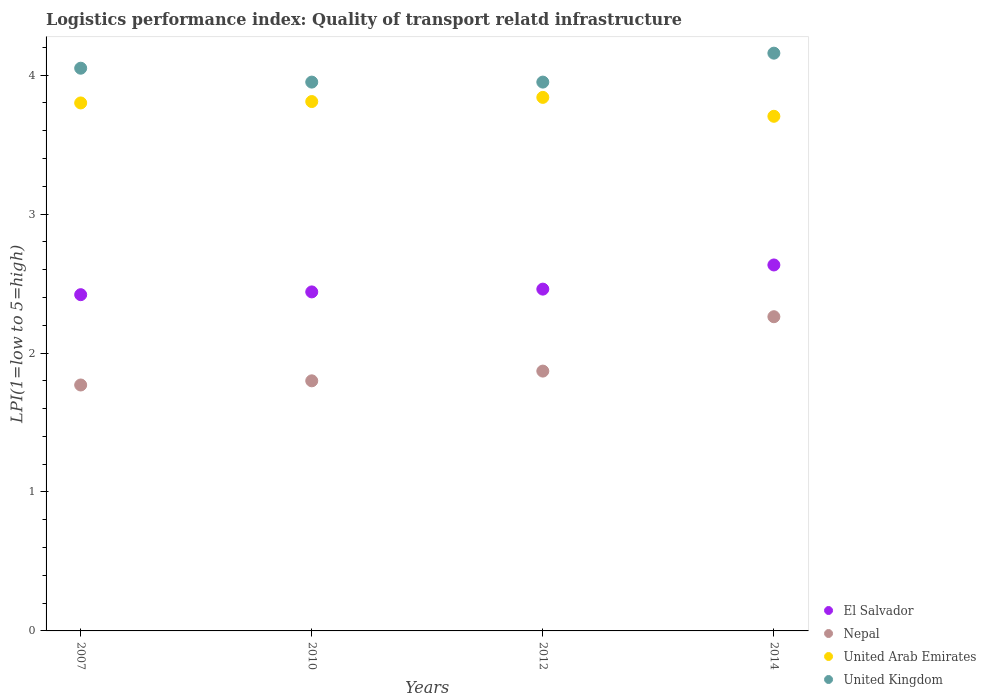How many different coloured dotlines are there?
Give a very brief answer. 4. Is the number of dotlines equal to the number of legend labels?
Provide a short and direct response. Yes. What is the logistics performance index in United Kingdom in 2012?
Make the answer very short. 3.95. Across all years, what is the maximum logistics performance index in United Arab Emirates?
Provide a short and direct response. 3.84. Across all years, what is the minimum logistics performance index in United Kingdom?
Your answer should be very brief. 3.95. What is the total logistics performance index in United Kingdom in the graph?
Give a very brief answer. 16.11. What is the difference between the logistics performance index in United Kingdom in 2012 and that in 2014?
Offer a terse response. -0.21. What is the difference between the logistics performance index in United Arab Emirates in 2012 and the logistics performance index in Nepal in 2010?
Provide a succinct answer. 2.04. What is the average logistics performance index in Nepal per year?
Keep it short and to the point. 1.93. In the year 2010, what is the difference between the logistics performance index in El Salvador and logistics performance index in United Kingdom?
Make the answer very short. -1.51. In how many years, is the logistics performance index in United Arab Emirates greater than 0.2?
Keep it short and to the point. 4. What is the ratio of the logistics performance index in El Salvador in 2007 to that in 2012?
Your response must be concise. 0.98. What is the difference between the highest and the second highest logistics performance index in El Salvador?
Provide a short and direct response. 0.17. What is the difference between the highest and the lowest logistics performance index in Nepal?
Keep it short and to the point. 0.49. Is the sum of the logistics performance index in El Salvador in 2012 and 2014 greater than the maximum logistics performance index in United Kingdom across all years?
Make the answer very short. Yes. Is the logistics performance index in El Salvador strictly greater than the logistics performance index in Nepal over the years?
Your response must be concise. Yes. Is the logistics performance index in Nepal strictly less than the logistics performance index in El Salvador over the years?
Provide a succinct answer. Yes. How many dotlines are there?
Offer a very short reply. 4. How many years are there in the graph?
Your answer should be compact. 4. Are the values on the major ticks of Y-axis written in scientific E-notation?
Provide a succinct answer. No. Does the graph contain any zero values?
Provide a succinct answer. No. How are the legend labels stacked?
Offer a very short reply. Vertical. What is the title of the graph?
Give a very brief answer. Logistics performance index: Quality of transport relatd infrastructure. Does "Senegal" appear as one of the legend labels in the graph?
Provide a succinct answer. No. What is the label or title of the X-axis?
Provide a short and direct response. Years. What is the label or title of the Y-axis?
Provide a short and direct response. LPI(1=low to 5=high). What is the LPI(1=low to 5=high) in El Salvador in 2007?
Keep it short and to the point. 2.42. What is the LPI(1=low to 5=high) in Nepal in 2007?
Keep it short and to the point. 1.77. What is the LPI(1=low to 5=high) of United Kingdom in 2007?
Your answer should be compact. 4.05. What is the LPI(1=low to 5=high) of El Salvador in 2010?
Offer a terse response. 2.44. What is the LPI(1=low to 5=high) of United Arab Emirates in 2010?
Your answer should be very brief. 3.81. What is the LPI(1=low to 5=high) of United Kingdom in 2010?
Keep it short and to the point. 3.95. What is the LPI(1=low to 5=high) in El Salvador in 2012?
Your answer should be compact. 2.46. What is the LPI(1=low to 5=high) in Nepal in 2012?
Ensure brevity in your answer.  1.87. What is the LPI(1=low to 5=high) of United Arab Emirates in 2012?
Your answer should be very brief. 3.84. What is the LPI(1=low to 5=high) in United Kingdom in 2012?
Your response must be concise. 3.95. What is the LPI(1=low to 5=high) of El Salvador in 2014?
Your response must be concise. 2.63. What is the LPI(1=low to 5=high) in Nepal in 2014?
Give a very brief answer. 2.26. What is the LPI(1=low to 5=high) in United Arab Emirates in 2014?
Make the answer very short. 3.7. What is the LPI(1=low to 5=high) in United Kingdom in 2014?
Keep it short and to the point. 4.16. Across all years, what is the maximum LPI(1=low to 5=high) of El Salvador?
Provide a short and direct response. 2.63. Across all years, what is the maximum LPI(1=low to 5=high) in Nepal?
Ensure brevity in your answer.  2.26. Across all years, what is the maximum LPI(1=low to 5=high) of United Arab Emirates?
Ensure brevity in your answer.  3.84. Across all years, what is the maximum LPI(1=low to 5=high) of United Kingdom?
Your response must be concise. 4.16. Across all years, what is the minimum LPI(1=low to 5=high) of El Salvador?
Keep it short and to the point. 2.42. Across all years, what is the minimum LPI(1=low to 5=high) of Nepal?
Ensure brevity in your answer.  1.77. Across all years, what is the minimum LPI(1=low to 5=high) in United Arab Emirates?
Give a very brief answer. 3.7. Across all years, what is the minimum LPI(1=low to 5=high) in United Kingdom?
Your answer should be compact. 3.95. What is the total LPI(1=low to 5=high) of El Salvador in the graph?
Your answer should be very brief. 9.95. What is the total LPI(1=low to 5=high) in Nepal in the graph?
Provide a short and direct response. 7.7. What is the total LPI(1=low to 5=high) of United Arab Emirates in the graph?
Your response must be concise. 15.15. What is the total LPI(1=low to 5=high) of United Kingdom in the graph?
Offer a terse response. 16.11. What is the difference between the LPI(1=low to 5=high) of El Salvador in 2007 and that in 2010?
Ensure brevity in your answer.  -0.02. What is the difference between the LPI(1=low to 5=high) in Nepal in 2007 and that in 2010?
Your response must be concise. -0.03. What is the difference between the LPI(1=low to 5=high) in United Arab Emirates in 2007 and that in 2010?
Provide a succinct answer. -0.01. What is the difference between the LPI(1=low to 5=high) in United Kingdom in 2007 and that in 2010?
Offer a very short reply. 0.1. What is the difference between the LPI(1=low to 5=high) in El Salvador in 2007 and that in 2012?
Provide a short and direct response. -0.04. What is the difference between the LPI(1=low to 5=high) in Nepal in 2007 and that in 2012?
Your answer should be compact. -0.1. What is the difference between the LPI(1=low to 5=high) in United Arab Emirates in 2007 and that in 2012?
Provide a succinct answer. -0.04. What is the difference between the LPI(1=low to 5=high) of United Kingdom in 2007 and that in 2012?
Offer a very short reply. 0.1. What is the difference between the LPI(1=low to 5=high) of El Salvador in 2007 and that in 2014?
Make the answer very short. -0.21. What is the difference between the LPI(1=low to 5=high) in Nepal in 2007 and that in 2014?
Offer a terse response. -0.49. What is the difference between the LPI(1=low to 5=high) of United Arab Emirates in 2007 and that in 2014?
Offer a terse response. 0.1. What is the difference between the LPI(1=low to 5=high) in United Kingdom in 2007 and that in 2014?
Provide a succinct answer. -0.11. What is the difference between the LPI(1=low to 5=high) in El Salvador in 2010 and that in 2012?
Offer a terse response. -0.02. What is the difference between the LPI(1=low to 5=high) of Nepal in 2010 and that in 2012?
Your response must be concise. -0.07. What is the difference between the LPI(1=low to 5=high) in United Arab Emirates in 2010 and that in 2012?
Ensure brevity in your answer.  -0.03. What is the difference between the LPI(1=low to 5=high) in United Kingdom in 2010 and that in 2012?
Give a very brief answer. 0. What is the difference between the LPI(1=low to 5=high) of El Salvador in 2010 and that in 2014?
Give a very brief answer. -0.19. What is the difference between the LPI(1=low to 5=high) in Nepal in 2010 and that in 2014?
Provide a succinct answer. -0.46. What is the difference between the LPI(1=low to 5=high) in United Arab Emirates in 2010 and that in 2014?
Offer a terse response. 0.11. What is the difference between the LPI(1=low to 5=high) of United Kingdom in 2010 and that in 2014?
Provide a succinct answer. -0.21. What is the difference between the LPI(1=low to 5=high) of El Salvador in 2012 and that in 2014?
Offer a terse response. -0.17. What is the difference between the LPI(1=low to 5=high) of Nepal in 2012 and that in 2014?
Offer a terse response. -0.39. What is the difference between the LPI(1=low to 5=high) of United Arab Emirates in 2012 and that in 2014?
Offer a very short reply. 0.14. What is the difference between the LPI(1=low to 5=high) in United Kingdom in 2012 and that in 2014?
Provide a short and direct response. -0.21. What is the difference between the LPI(1=low to 5=high) of El Salvador in 2007 and the LPI(1=low to 5=high) of Nepal in 2010?
Keep it short and to the point. 0.62. What is the difference between the LPI(1=low to 5=high) in El Salvador in 2007 and the LPI(1=low to 5=high) in United Arab Emirates in 2010?
Your answer should be very brief. -1.39. What is the difference between the LPI(1=low to 5=high) of El Salvador in 2007 and the LPI(1=low to 5=high) of United Kingdom in 2010?
Offer a terse response. -1.53. What is the difference between the LPI(1=low to 5=high) in Nepal in 2007 and the LPI(1=low to 5=high) in United Arab Emirates in 2010?
Offer a terse response. -2.04. What is the difference between the LPI(1=low to 5=high) in Nepal in 2007 and the LPI(1=low to 5=high) in United Kingdom in 2010?
Offer a terse response. -2.18. What is the difference between the LPI(1=low to 5=high) of United Arab Emirates in 2007 and the LPI(1=low to 5=high) of United Kingdom in 2010?
Offer a terse response. -0.15. What is the difference between the LPI(1=low to 5=high) of El Salvador in 2007 and the LPI(1=low to 5=high) of Nepal in 2012?
Provide a succinct answer. 0.55. What is the difference between the LPI(1=low to 5=high) of El Salvador in 2007 and the LPI(1=low to 5=high) of United Arab Emirates in 2012?
Offer a terse response. -1.42. What is the difference between the LPI(1=low to 5=high) of El Salvador in 2007 and the LPI(1=low to 5=high) of United Kingdom in 2012?
Keep it short and to the point. -1.53. What is the difference between the LPI(1=low to 5=high) in Nepal in 2007 and the LPI(1=low to 5=high) in United Arab Emirates in 2012?
Give a very brief answer. -2.07. What is the difference between the LPI(1=low to 5=high) of Nepal in 2007 and the LPI(1=low to 5=high) of United Kingdom in 2012?
Provide a succinct answer. -2.18. What is the difference between the LPI(1=low to 5=high) of United Arab Emirates in 2007 and the LPI(1=low to 5=high) of United Kingdom in 2012?
Give a very brief answer. -0.15. What is the difference between the LPI(1=low to 5=high) in El Salvador in 2007 and the LPI(1=low to 5=high) in Nepal in 2014?
Your response must be concise. 0.16. What is the difference between the LPI(1=low to 5=high) of El Salvador in 2007 and the LPI(1=low to 5=high) of United Arab Emirates in 2014?
Your response must be concise. -1.28. What is the difference between the LPI(1=low to 5=high) in El Salvador in 2007 and the LPI(1=low to 5=high) in United Kingdom in 2014?
Offer a very short reply. -1.74. What is the difference between the LPI(1=low to 5=high) in Nepal in 2007 and the LPI(1=low to 5=high) in United Arab Emirates in 2014?
Give a very brief answer. -1.93. What is the difference between the LPI(1=low to 5=high) of Nepal in 2007 and the LPI(1=low to 5=high) of United Kingdom in 2014?
Keep it short and to the point. -2.39. What is the difference between the LPI(1=low to 5=high) in United Arab Emirates in 2007 and the LPI(1=low to 5=high) in United Kingdom in 2014?
Your response must be concise. -0.36. What is the difference between the LPI(1=low to 5=high) of El Salvador in 2010 and the LPI(1=low to 5=high) of Nepal in 2012?
Provide a short and direct response. 0.57. What is the difference between the LPI(1=low to 5=high) of El Salvador in 2010 and the LPI(1=low to 5=high) of United Arab Emirates in 2012?
Keep it short and to the point. -1.4. What is the difference between the LPI(1=low to 5=high) in El Salvador in 2010 and the LPI(1=low to 5=high) in United Kingdom in 2012?
Provide a short and direct response. -1.51. What is the difference between the LPI(1=low to 5=high) in Nepal in 2010 and the LPI(1=low to 5=high) in United Arab Emirates in 2012?
Ensure brevity in your answer.  -2.04. What is the difference between the LPI(1=low to 5=high) of Nepal in 2010 and the LPI(1=low to 5=high) of United Kingdom in 2012?
Your answer should be compact. -2.15. What is the difference between the LPI(1=low to 5=high) of United Arab Emirates in 2010 and the LPI(1=low to 5=high) of United Kingdom in 2012?
Ensure brevity in your answer.  -0.14. What is the difference between the LPI(1=low to 5=high) in El Salvador in 2010 and the LPI(1=low to 5=high) in Nepal in 2014?
Ensure brevity in your answer.  0.18. What is the difference between the LPI(1=low to 5=high) of El Salvador in 2010 and the LPI(1=low to 5=high) of United Arab Emirates in 2014?
Give a very brief answer. -1.26. What is the difference between the LPI(1=low to 5=high) of El Salvador in 2010 and the LPI(1=low to 5=high) of United Kingdom in 2014?
Offer a terse response. -1.72. What is the difference between the LPI(1=low to 5=high) in Nepal in 2010 and the LPI(1=low to 5=high) in United Arab Emirates in 2014?
Provide a short and direct response. -1.9. What is the difference between the LPI(1=low to 5=high) in Nepal in 2010 and the LPI(1=low to 5=high) in United Kingdom in 2014?
Give a very brief answer. -2.36. What is the difference between the LPI(1=low to 5=high) in United Arab Emirates in 2010 and the LPI(1=low to 5=high) in United Kingdom in 2014?
Give a very brief answer. -0.35. What is the difference between the LPI(1=low to 5=high) of El Salvador in 2012 and the LPI(1=low to 5=high) of Nepal in 2014?
Provide a succinct answer. 0.2. What is the difference between the LPI(1=low to 5=high) of El Salvador in 2012 and the LPI(1=low to 5=high) of United Arab Emirates in 2014?
Give a very brief answer. -1.24. What is the difference between the LPI(1=low to 5=high) in El Salvador in 2012 and the LPI(1=low to 5=high) in United Kingdom in 2014?
Offer a terse response. -1.7. What is the difference between the LPI(1=low to 5=high) of Nepal in 2012 and the LPI(1=low to 5=high) of United Arab Emirates in 2014?
Offer a terse response. -1.83. What is the difference between the LPI(1=low to 5=high) of Nepal in 2012 and the LPI(1=low to 5=high) of United Kingdom in 2014?
Ensure brevity in your answer.  -2.29. What is the difference between the LPI(1=low to 5=high) of United Arab Emirates in 2012 and the LPI(1=low to 5=high) of United Kingdom in 2014?
Provide a succinct answer. -0.32. What is the average LPI(1=low to 5=high) in El Salvador per year?
Keep it short and to the point. 2.49. What is the average LPI(1=low to 5=high) in Nepal per year?
Keep it short and to the point. 1.93. What is the average LPI(1=low to 5=high) of United Arab Emirates per year?
Provide a short and direct response. 3.79. What is the average LPI(1=low to 5=high) of United Kingdom per year?
Give a very brief answer. 4.03. In the year 2007, what is the difference between the LPI(1=low to 5=high) of El Salvador and LPI(1=low to 5=high) of Nepal?
Provide a succinct answer. 0.65. In the year 2007, what is the difference between the LPI(1=low to 5=high) in El Salvador and LPI(1=low to 5=high) in United Arab Emirates?
Keep it short and to the point. -1.38. In the year 2007, what is the difference between the LPI(1=low to 5=high) in El Salvador and LPI(1=low to 5=high) in United Kingdom?
Keep it short and to the point. -1.63. In the year 2007, what is the difference between the LPI(1=low to 5=high) in Nepal and LPI(1=low to 5=high) in United Arab Emirates?
Provide a succinct answer. -2.03. In the year 2007, what is the difference between the LPI(1=low to 5=high) in Nepal and LPI(1=low to 5=high) in United Kingdom?
Offer a very short reply. -2.28. In the year 2007, what is the difference between the LPI(1=low to 5=high) of United Arab Emirates and LPI(1=low to 5=high) of United Kingdom?
Make the answer very short. -0.25. In the year 2010, what is the difference between the LPI(1=low to 5=high) of El Salvador and LPI(1=low to 5=high) of Nepal?
Keep it short and to the point. 0.64. In the year 2010, what is the difference between the LPI(1=low to 5=high) in El Salvador and LPI(1=low to 5=high) in United Arab Emirates?
Provide a short and direct response. -1.37. In the year 2010, what is the difference between the LPI(1=low to 5=high) of El Salvador and LPI(1=low to 5=high) of United Kingdom?
Keep it short and to the point. -1.51. In the year 2010, what is the difference between the LPI(1=low to 5=high) in Nepal and LPI(1=low to 5=high) in United Arab Emirates?
Provide a succinct answer. -2.01. In the year 2010, what is the difference between the LPI(1=low to 5=high) of Nepal and LPI(1=low to 5=high) of United Kingdom?
Your answer should be very brief. -2.15. In the year 2010, what is the difference between the LPI(1=low to 5=high) in United Arab Emirates and LPI(1=low to 5=high) in United Kingdom?
Your response must be concise. -0.14. In the year 2012, what is the difference between the LPI(1=low to 5=high) in El Salvador and LPI(1=low to 5=high) in Nepal?
Offer a terse response. 0.59. In the year 2012, what is the difference between the LPI(1=low to 5=high) of El Salvador and LPI(1=low to 5=high) of United Arab Emirates?
Make the answer very short. -1.38. In the year 2012, what is the difference between the LPI(1=low to 5=high) of El Salvador and LPI(1=low to 5=high) of United Kingdom?
Provide a short and direct response. -1.49. In the year 2012, what is the difference between the LPI(1=low to 5=high) of Nepal and LPI(1=low to 5=high) of United Arab Emirates?
Offer a very short reply. -1.97. In the year 2012, what is the difference between the LPI(1=low to 5=high) in Nepal and LPI(1=low to 5=high) in United Kingdom?
Keep it short and to the point. -2.08. In the year 2012, what is the difference between the LPI(1=low to 5=high) of United Arab Emirates and LPI(1=low to 5=high) of United Kingdom?
Keep it short and to the point. -0.11. In the year 2014, what is the difference between the LPI(1=low to 5=high) in El Salvador and LPI(1=low to 5=high) in Nepal?
Make the answer very short. 0.37. In the year 2014, what is the difference between the LPI(1=low to 5=high) in El Salvador and LPI(1=low to 5=high) in United Arab Emirates?
Your response must be concise. -1.07. In the year 2014, what is the difference between the LPI(1=low to 5=high) in El Salvador and LPI(1=low to 5=high) in United Kingdom?
Offer a very short reply. -1.52. In the year 2014, what is the difference between the LPI(1=low to 5=high) of Nepal and LPI(1=low to 5=high) of United Arab Emirates?
Your response must be concise. -1.44. In the year 2014, what is the difference between the LPI(1=low to 5=high) of Nepal and LPI(1=low to 5=high) of United Kingdom?
Your answer should be compact. -1.9. In the year 2014, what is the difference between the LPI(1=low to 5=high) of United Arab Emirates and LPI(1=low to 5=high) of United Kingdom?
Offer a terse response. -0.45. What is the ratio of the LPI(1=low to 5=high) in El Salvador in 2007 to that in 2010?
Your answer should be compact. 0.99. What is the ratio of the LPI(1=low to 5=high) of Nepal in 2007 to that in 2010?
Offer a terse response. 0.98. What is the ratio of the LPI(1=low to 5=high) in United Kingdom in 2007 to that in 2010?
Offer a very short reply. 1.03. What is the ratio of the LPI(1=low to 5=high) of El Salvador in 2007 to that in 2012?
Make the answer very short. 0.98. What is the ratio of the LPI(1=low to 5=high) of Nepal in 2007 to that in 2012?
Your answer should be compact. 0.95. What is the ratio of the LPI(1=low to 5=high) in United Kingdom in 2007 to that in 2012?
Provide a short and direct response. 1.03. What is the ratio of the LPI(1=low to 5=high) in El Salvador in 2007 to that in 2014?
Offer a terse response. 0.92. What is the ratio of the LPI(1=low to 5=high) in Nepal in 2007 to that in 2014?
Offer a very short reply. 0.78. What is the ratio of the LPI(1=low to 5=high) of United Arab Emirates in 2007 to that in 2014?
Provide a succinct answer. 1.03. What is the ratio of the LPI(1=low to 5=high) in United Kingdom in 2007 to that in 2014?
Ensure brevity in your answer.  0.97. What is the ratio of the LPI(1=low to 5=high) of El Salvador in 2010 to that in 2012?
Your response must be concise. 0.99. What is the ratio of the LPI(1=low to 5=high) of Nepal in 2010 to that in 2012?
Provide a succinct answer. 0.96. What is the ratio of the LPI(1=low to 5=high) in United Kingdom in 2010 to that in 2012?
Keep it short and to the point. 1. What is the ratio of the LPI(1=low to 5=high) of El Salvador in 2010 to that in 2014?
Offer a terse response. 0.93. What is the ratio of the LPI(1=low to 5=high) in Nepal in 2010 to that in 2014?
Keep it short and to the point. 0.8. What is the ratio of the LPI(1=low to 5=high) of United Arab Emirates in 2010 to that in 2014?
Your answer should be compact. 1.03. What is the ratio of the LPI(1=low to 5=high) in United Kingdom in 2010 to that in 2014?
Your response must be concise. 0.95. What is the ratio of the LPI(1=low to 5=high) of El Salvador in 2012 to that in 2014?
Your answer should be very brief. 0.93. What is the ratio of the LPI(1=low to 5=high) in Nepal in 2012 to that in 2014?
Your response must be concise. 0.83. What is the ratio of the LPI(1=low to 5=high) of United Arab Emirates in 2012 to that in 2014?
Provide a short and direct response. 1.04. What is the ratio of the LPI(1=low to 5=high) in United Kingdom in 2012 to that in 2014?
Give a very brief answer. 0.95. What is the difference between the highest and the second highest LPI(1=low to 5=high) in El Salvador?
Keep it short and to the point. 0.17. What is the difference between the highest and the second highest LPI(1=low to 5=high) of Nepal?
Offer a terse response. 0.39. What is the difference between the highest and the second highest LPI(1=low to 5=high) of United Kingdom?
Your response must be concise. 0.11. What is the difference between the highest and the lowest LPI(1=low to 5=high) in El Salvador?
Ensure brevity in your answer.  0.21. What is the difference between the highest and the lowest LPI(1=low to 5=high) of Nepal?
Offer a very short reply. 0.49. What is the difference between the highest and the lowest LPI(1=low to 5=high) in United Arab Emirates?
Your answer should be very brief. 0.14. What is the difference between the highest and the lowest LPI(1=low to 5=high) of United Kingdom?
Offer a very short reply. 0.21. 